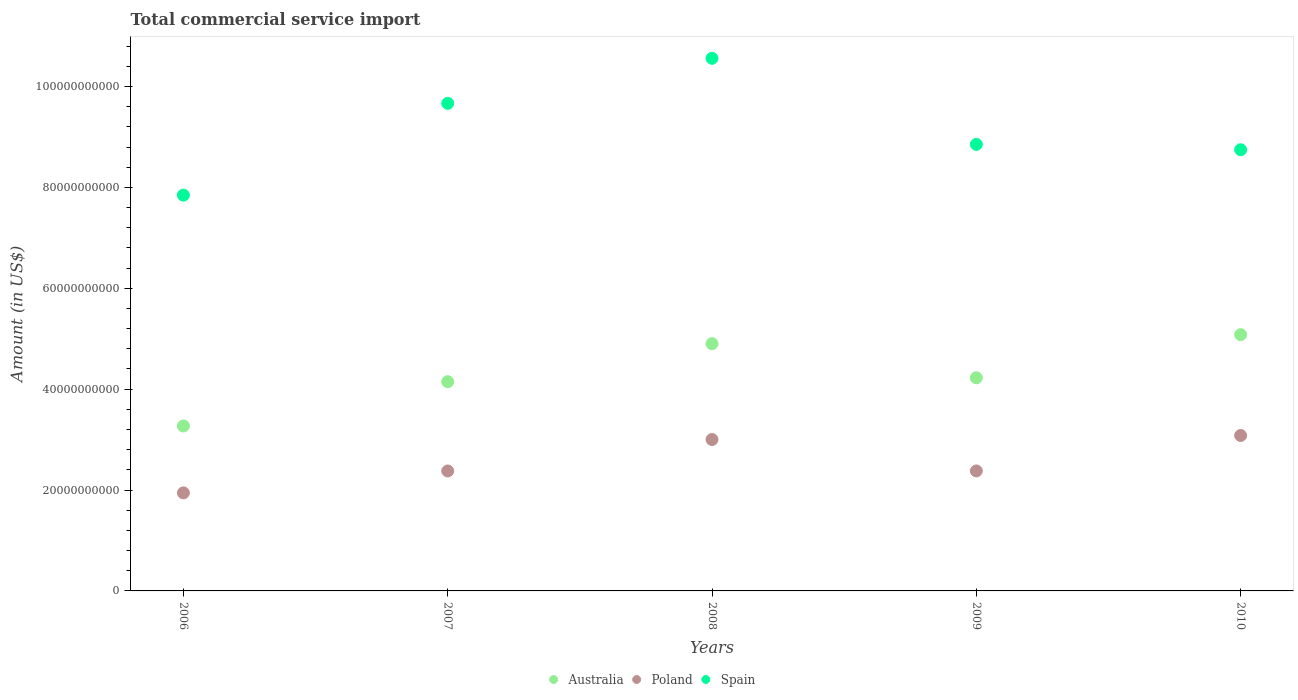How many different coloured dotlines are there?
Offer a very short reply. 3. Is the number of dotlines equal to the number of legend labels?
Make the answer very short. Yes. What is the total commercial service import in Spain in 2008?
Your answer should be very brief. 1.06e+11. Across all years, what is the maximum total commercial service import in Australia?
Ensure brevity in your answer.  5.08e+1. Across all years, what is the minimum total commercial service import in Australia?
Provide a succinct answer. 3.27e+1. In which year was the total commercial service import in Spain minimum?
Your response must be concise. 2006. What is the total total commercial service import in Spain in the graph?
Offer a terse response. 4.57e+11. What is the difference between the total commercial service import in Poland in 2007 and that in 2010?
Make the answer very short. -7.04e+09. What is the difference between the total commercial service import in Australia in 2007 and the total commercial service import in Poland in 2008?
Provide a short and direct response. 1.15e+1. What is the average total commercial service import in Spain per year?
Give a very brief answer. 9.13e+1. In the year 2008, what is the difference between the total commercial service import in Poland and total commercial service import in Australia?
Provide a short and direct response. -1.90e+1. What is the ratio of the total commercial service import in Spain in 2006 to that in 2007?
Give a very brief answer. 0.81. What is the difference between the highest and the second highest total commercial service import in Spain?
Provide a short and direct response. 8.93e+09. What is the difference between the highest and the lowest total commercial service import in Australia?
Offer a very short reply. 1.81e+1. In how many years, is the total commercial service import in Australia greater than the average total commercial service import in Australia taken over all years?
Make the answer very short. 2. Is the sum of the total commercial service import in Spain in 2007 and 2008 greater than the maximum total commercial service import in Australia across all years?
Your response must be concise. Yes. Is it the case that in every year, the sum of the total commercial service import in Australia and total commercial service import in Spain  is greater than the total commercial service import in Poland?
Provide a succinct answer. Yes. Is the total commercial service import in Spain strictly greater than the total commercial service import in Poland over the years?
Provide a succinct answer. Yes. Is the total commercial service import in Australia strictly less than the total commercial service import in Poland over the years?
Offer a terse response. No. How many years are there in the graph?
Offer a very short reply. 5. Does the graph contain any zero values?
Give a very brief answer. No. How many legend labels are there?
Make the answer very short. 3. How are the legend labels stacked?
Provide a succinct answer. Horizontal. What is the title of the graph?
Make the answer very short. Total commercial service import. Does "Jamaica" appear as one of the legend labels in the graph?
Offer a very short reply. No. What is the label or title of the X-axis?
Your response must be concise. Years. What is the Amount (in US$) of Australia in 2006?
Your answer should be compact. 3.27e+1. What is the Amount (in US$) of Poland in 2006?
Your response must be concise. 1.94e+1. What is the Amount (in US$) of Spain in 2006?
Give a very brief answer. 7.85e+1. What is the Amount (in US$) in Australia in 2007?
Give a very brief answer. 4.15e+1. What is the Amount (in US$) in Poland in 2007?
Offer a very short reply. 2.38e+1. What is the Amount (in US$) in Spain in 2007?
Offer a terse response. 9.67e+1. What is the Amount (in US$) of Australia in 2008?
Your answer should be very brief. 4.90e+1. What is the Amount (in US$) in Poland in 2008?
Your answer should be compact. 3.00e+1. What is the Amount (in US$) in Spain in 2008?
Your answer should be compact. 1.06e+11. What is the Amount (in US$) of Australia in 2009?
Offer a terse response. 4.23e+1. What is the Amount (in US$) of Poland in 2009?
Provide a short and direct response. 2.38e+1. What is the Amount (in US$) of Spain in 2009?
Offer a terse response. 8.85e+1. What is the Amount (in US$) in Australia in 2010?
Your answer should be very brief. 5.08e+1. What is the Amount (in US$) of Poland in 2010?
Provide a short and direct response. 3.08e+1. What is the Amount (in US$) of Spain in 2010?
Your response must be concise. 8.75e+1. Across all years, what is the maximum Amount (in US$) in Australia?
Offer a terse response. 5.08e+1. Across all years, what is the maximum Amount (in US$) of Poland?
Provide a succinct answer. 3.08e+1. Across all years, what is the maximum Amount (in US$) in Spain?
Your response must be concise. 1.06e+11. Across all years, what is the minimum Amount (in US$) of Australia?
Offer a very short reply. 3.27e+1. Across all years, what is the minimum Amount (in US$) of Poland?
Ensure brevity in your answer.  1.94e+1. Across all years, what is the minimum Amount (in US$) of Spain?
Keep it short and to the point. 7.85e+1. What is the total Amount (in US$) in Australia in the graph?
Your answer should be very brief. 2.16e+11. What is the total Amount (in US$) of Poland in the graph?
Offer a very short reply. 1.28e+11. What is the total Amount (in US$) of Spain in the graph?
Your answer should be compact. 4.57e+11. What is the difference between the Amount (in US$) in Australia in 2006 and that in 2007?
Offer a terse response. -8.78e+09. What is the difference between the Amount (in US$) of Poland in 2006 and that in 2007?
Ensure brevity in your answer.  -4.34e+09. What is the difference between the Amount (in US$) in Spain in 2006 and that in 2007?
Give a very brief answer. -1.82e+1. What is the difference between the Amount (in US$) of Australia in 2006 and that in 2008?
Your answer should be compact. -1.63e+1. What is the difference between the Amount (in US$) in Poland in 2006 and that in 2008?
Ensure brevity in your answer.  -1.06e+1. What is the difference between the Amount (in US$) of Spain in 2006 and that in 2008?
Ensure brevity in your answer.  -2.71e+1. What is the difference between the Amount (in US$) in Australia in 2006 and that in 2009?
Provide a succinct answer. -9.56e+09. What is the difference between the Amount (in US$) in Poland in 2006 and that in 2009?
Your answer should be compact. -4.35e+09. What is the difference between the Amount (in US$) in Spain in 2006 and that in 2009?
Make the answer very short. -1.01e+1. What is the difference between the Amount (in US$) of Australia in 2006 and that in 2010?
Provide a succinct answer. -1.81e+1. What is the difference between the Amount (in US$) of Poland in 2006 and that in 2010?
Provide a succinct answer. -1.14e+1. What is the difference between the Amount (in US$) of Spain in 2006 and that in 2010?
Your answer should be very brief. -9.00e+09. What is the difference between the Amount (in US$) in Australia in 2007 and that in 2008?
Ensure brevity in your answer.  -7.54e+09. What is the difference between the Amount (in US$) of Poland in 2007 and that in 2008?
Provide a short and direct response. -6.24e+09. What is the difference between the Amount (in US$) in Spain in 2007 and that in 2008?
Make the answer very short. -8.93e+09. What is the difference between the Amount (in US$) in Australia in 2007 and that in 2009?
Your answer should be compact. -7.81e+08. What is the difference between the Amount (in US$) in Poland in 2007 and that in 2009?
Your answer should be compact. -9.00e+06. What is the difference between the Amount (in US$) in Spain in 2007 and that in 2009?
Give a very brief answer. 8.14e+09. What is the difference between the Amount (in US$) in Australia in 2007 and that in 2010?
Ensure brevity in your answer.  -9.33e+09. What is the difference between the Amount (in US$) of Poland in 2007 and that in 2010?
Your answer should be compact. -7.04e+09. What is the difference between the Amount (in US$) in Spain in 2007 and that in 2010?
Provide a short and direct response. 9.20e+09. What is the difference between the Amount (in US$) in Australia in 2008 and that in 2009?
Keep it short and to the point. 6.76e+09. What is the difference between the Amount (in US$) in Poland in 2008 and that in 2009?
Ensure brevity in your answer.  6.23e+09. What is the difference between the Amount (in US$) of Spain in 2008 and that in 2009?
Offer a terse response. 1.71e+1. What is the difference between the Amount (in US$) in Australia in 2008 and that in 2010?
Give a very brief answer. -1.79e+09. What is the difference between the Amount (in US$) in Poland in 2008 and that in 2010?
Provide a succinct answer. -8.00e+08. What is the difference between the Amount (in US$) in Spain in 2008 and that in 2010?
Your answer should be compact. 1.81e+1. What is the difference between the Amount (in US$) of Australia in 2009 and that in 2010?
Ensure brevity in your answer.  -8.55e+09. What is the difference between the Amount (in US$) of Poland in 2009 and that in 2010?
Provide a short and direct response. -7.03e+09. What is the difference between the Amount (in US$) of Spain in 2009 and that in 2010?
Your answer should be very brief. 1.06e+09. What is the difference between the Amount (in US$) of Australia in 2006 and the Amount (in US$) of Poland in 2007?
Your response must be concise. 8.92e+09. What is the difference between the Amount (in US$) in Australia in 2006 and the Amount (in US$) in Spain in 2007?
Your answer should be very brief. -6.40e+1. What is the difference between the Amount (in US$) of Poland in 2006 and the Amount (in US$) of Spain in 2007?
Provide a short and direct response. -7.72e+1. What is the difference between the Amount (in US$) in Australia in 2006 and the Amount (in US$) in Poland in 2008?
Make the answer very short. 2.68e+09. What is the difference between the Amount (in US$) in Australia in 2006 and the Amount (in US$) in Spain in 2008?
Make the answer very short. -7.29e+1. What is the difference between the Amount (in US$) in Poland in 2006 and the Amount (in US$) in Spain in 2008?
Keep it short and to the point. -8.62e+1. What is the difference between the Amount (in US$) of Australia in 2006 and the Amount (in US$) of Poland in 2009?
Ensure brevity in your answer.  8.91e+09. What is the difference between the Amount (in US$) in Australia in 2006 and the Amount (in US$) in Spain in 2009?
Your answer should be very brief. -5.58e+1. What is the difference between the Amount (in US$) in Poland in 2006 and the Amount (in US$) in Spain in 2009?
Ensure brevity in your answer.  -6.91e+1. What is the difference between the Amount (in US$) in Australia in 2006 and the Amount (in US$) in Poland in 2010?
Keep it short and to the point. 1.88e+09. What is the difference between the Amount (in US$) in Australia in 2006 and the Amount (in US$) in Spain in 2010?
Offer a very short reply. -5.48e+1. What is the difference between the Amount (in US$) of Poland in 2006 and the Amount (in US$) of Spain in 2010?
Offer a terse response. -6.80e+1. What is the difference between the Amount (in US$) in Australia in 2007 and the Amount (in US$) in Poland in 2008?
Ensure brevity in your answer.  1.15e+1. What is the difference between the Amount (in US$) of Australia in 2007 and the Amount (in US$) of Spain in 2008?
Offer a terse response. -6.41e+1. What is the difference between the Amount (in US$) in Poland in 2007 and the Amount (in US$) in Spain in 2008?
Keep it short and to the point. -8.18e+1. What is the difference between the Amount (in US$) of Australia in 2007 and the Amount (in US$) of Poland in 2009?
Offer a very short reply. 1.77e+1. What is the difference between the Amount (in US$) of Australia in 2007 and the Amount (in US$) of Spain in 2009?
Offer a terse response. -4.70e+1. What is the difference between the Amount (in US$) of Poland in 2007 and the Amount (in US$) of Spain in 2009?
Provide a short and direct response. -6.47e+1. What is the difference between the Amount (in US$) in Australia in 2007 and the Amount (in US$) in Poland in 2010?
Ensure brevity in your answer.  1.07e+1. What is the difference between the Amount (in US$) in Australia in 2007 and the Amount (in US$) in Spain in 2010?
Your answer should be compact. -4.60e+1. What is the difference between the Amount (in US$) of Poland in 2007 and the Amount (in US$) of Spain in 2010?
Provide a succinct answer. -6.37e+1. What is the difference between the Amount (in US$) in Australia in 2008 and the Amount (in US$) in Poland in 2009?
Ensure brevity in your answer.  2.52e+1. What is the difference between the Amount (in US$) in Australia in 2008 and the Amount (in US$) in Spain in 2009?
Provide a short and direct response. -3.95e+1. What is the difference between the Amount (in US$) of Poland in 2008 and the Amount (in US$) of Spain in 2009?
Your answer should be compact. -5.85e+1. What is the difference between the Amount (in US$) of Australia in 2008 and the Amount (in US$) of Poland in 2010?
Make the answer very short. 1.82e+1. What is the difference between the Amount (in US$) in Australia in 2008 and the Amount (in US$) in Spain in 2010?
Provide a short and direct response. -3.84e+1. What is the difference between the Amount (in US$) of Poland in 2008 and the Amount (in US$) of Spain in 2010?
Your response must be concise. -5.74e+1. What is the difference between the Amount (in US$) of Australia in 2009 and the Amount (in US$) of Poland in 2010?
Offer a very short reply. 1.14e+1. What is the difference between the Amount (in US$) in Australia in 2009 and the Amount (in US$) in Spain in 2010?
Your answer should be very brief. -4.52e+1. What is the difference between the Amount (in US$) in Poland in 2009 and the Amount (in US$) in Spain in 2010?
Your answer should be compact. -6.37e+1. What is the average Amount (in US$) in Australia per year?
Your response must be concise. 4.33e+1. What is the average Amount (in US$) in Poland per year?
Your answer should be very brief. 2.56e+1. What is the average Amount (in US$) of Spain per year?
Offer a very short reply. 9.13e+1. In the year 2006, what is the difference between the Amount (in US$) in Australia and Amount (in US$) in Poland?
Give a very brief answer. 1.33e+1. In the year 2006, what is the difference between the Amount (in US$) in Australia and Amount (in US$) in Spain?
Ensure brevity in your answer.  -4.58e+1. In the year 2006, what is the difference between the Amount (in US$) of Poland and Amount (in US$) of Spain?
Offer a terse response. -5.90e+1. In the year 2007, what is the difference between the Amount (in US$) of Australia and Amount (in US$) of Poland?
Make the answer very short. 1.77e+1. In the year 2007, what is the difference between the Amount (in US$) in Australia and Amount (in US$) in Spain?
Ensure brevity in your answer.  -5.52e+1. In the year 2007, what is the difference between the Amount (in US$) of Poland and Amount (in US$) of Spain?
Make the answer very short. -7.29e+1. In the year 2008, what is the difference between the Amount (in US$) in Australia and Amount (in US$) in Poland?
Make the answer very short. 1.90e+1. In the year 2008, what is the difference between the Amount (in US$) in Australia and Amount (in US$) in Spain?
Provide a succinct answer. -5.66e+1. In the year 2008, what is the difference between the Amount (in US$) of Poland and Amount (in US$) of Spain?
Your answer should be very brief. -7.56e+1. In the year 2009, what is the difference between the Amount (in US$) in Australia and Amount (in US$) in Poland?
Make the answer very short. 1.85e+1. In the year 2009, what is the difference between the Amount (in US$) of Australia and Amount (in US$) of Spain?
Keep it short and to the point. -4.63e+1. In the year 2009, what is the difference between the Amount (in US$) of Poland and Amount (in US$) of Spain?
Your response must be concise. -6.47e+1. In the year 2010, what is the difference between the Amount (in US$) of Australia and Amount (in US$) of Poland?
Your answer should be very brief. 2.00e+1. In the year 2010, what is the difference between the Amount (in US$) in Australia and Amount (in US$) in Spain?
Keep it short and to the point. -3.67e+1. In the year 2010, what is the difference between the Amount (in US$) of Poland and Amount (in US$) of Spain?
Ensure brevity in your answer.  -5.66e+1. What is the ratio of the Amount (in US$) of Australia in 2006 to that in 2007?
Provide a short and direct response. 0.79. What is the ratio of the Amount (in US$) of Poland in 2006 to that in 2007?
Your response must be concise. 0.82. What is the ratio of the Amount (in US$) in Spain in 2006 to that in 2007?
Provide a succinct answer. 0.81. What is the ratio of the Amount (in US$) in Australia in 2006 to that in 2008?
Give a very brief answer. 0.67. What is the ratio of the Amount (in US$) in Poland in 2006 to that in 2008?
Offer a very short reply. 0.65. What is the ratio of the Amount (in US$) in Spain in 2006 to that in 2008?
Offer a very short reply. 0.74. What is the ratio of the Amount (in US$) of Australia in 2006 to that in 2009?
Your answer should be very brief. 0.77. What is the ratio of the Amount (in US$) of Poland in 2006 to that in 2009?
Give a very brief answer. 0.82. What is the ratio of the Amount (in US$) in Spain in 2006 to that in 2009?
Make the answer very short. 0.89. What is the ratio of the Amount (in US$) of Australia in 2006 to that in 2010?
Make the answer very short. 0.64. What is the ratio of the Amount (in US$) of Poland in 2006 to that in 2010?
Your answer should be very brief. 0.63. What is the ratio of the Amount (in US$) in Spain in 2006 to that in 2010?
Your answer should be very brief. 0.9. What is the ratio of the Amount (in US$) in Australia in 2007 to that in 2008?
Offer a very short reply. 0.85. What is the ratio of the Amount (in US$) in Poland in 2007 to that in 2008?
Offer a very short reply. 0.79. What is the ratio of the Amount (in US$) in Spain in 2007 to that in 2008?
Offer a terse response. 0.92. What is the ratio of the Amount (in US$) of Australia in 2007 to that in 2009?
Your answer should be compact. 0.98. What is the ratio of the Amount (in US$) of Spain in 2007 to that in 2009?
Your response must be concise. 1.09. What is the ratio of the Amount (in US$) of Australia in 2007 to that in 2010?
Provide a succinct answer. 0.82. What is the ratio of the Amount (in US$) in Poland in 2007 to that in 2010?
Your answer should be compact. 0.77. What is the ratio of the Amount (in US$) of Spain in 2007 to that in 2010?
Your answer should be very brief. 1.11. What is the ratio of the Amount (in US$) of Australia in 2008 to that in 2009?
Your answer should be very brief. 1.16. What is the ratio of the Amount (in US$) of Poland in 2008 to that in 2009?
Ensure brevity in your answer.  1.26. What is the ratio of the Amount (in US$) of Spain in 2008 to that in 2009?
Your answer should be compact. 1.19. What is the ratio of the Amount (in US$) of Australia in 2008 to that in 2010?
Give a very brief answer. 0.96. What is the ratio of the Amount (in US$) in Poland in 2008 to that in 2010?
Offer a terse response. 0.97. What is the ratio of the Amount (in US$) in Spain in 2008 to that in 2010?
Offer a very short reply. 1.21. What is the ratio of the Amount (in US$) in Australia in 2009 to that in 2010?
Provide a succinct answer. 0.83. What is the ratio of the Amount (in US$) in Poland in 2009 to that in 2010?
Make the answer very short. 0.77. What is the ratio of the Amount (in US$) in Spain in 2009 to that in 2010?
Ensure brevity in your answer.  1.01. What is the difference between the highest and the second highest Amount (in US$) of Australia?
Your answer should be very brief. 1.79e+09. What is the difference between the highest and the second highest Amount (in US$) of Poland?
Offer a very short reply. 8.00e+08. What is the difference between the highest and the second highest Amount (in US$) in Spain?
Your answer should be compact. 8.93e+09. What is the difference between the highest and the lowest Amount (in US$) of Australia?
Ensure brevity in your answer.  1.81e+1. What is the difference between the highest and the lowest Amount (in US$) in Poland?
Give a very brief answer. 1.14e+1. What is the difference between the highest and the lowest Amount (in US$) of Spain?
Make the answer very short. 2.71e+1. 